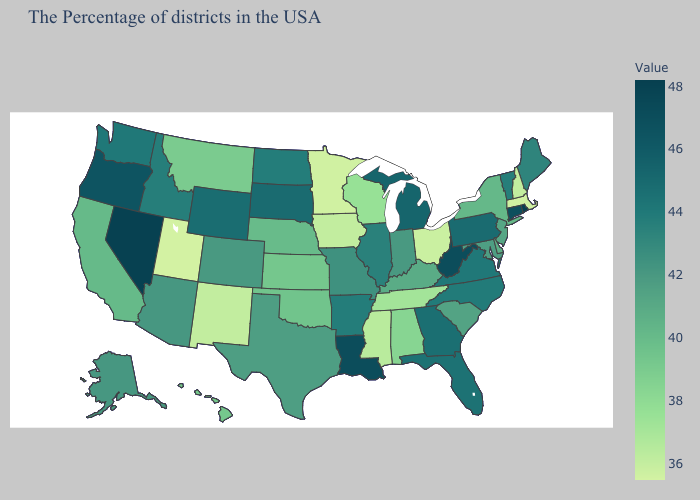Does Vermont have the highest value in the Northeast?
Give a very brief answer. No. Which states have the lowest value in the USA?
Be succinct. Utah. Among the states that border Wisconsin , does Michigan have the highest value?
Be succinct. Yes. Does Connecticut have the lowest value in the Northeast?
Be succinct. No. Which states have the highest value in the USA?
Answer briefly. Rhode Island. 